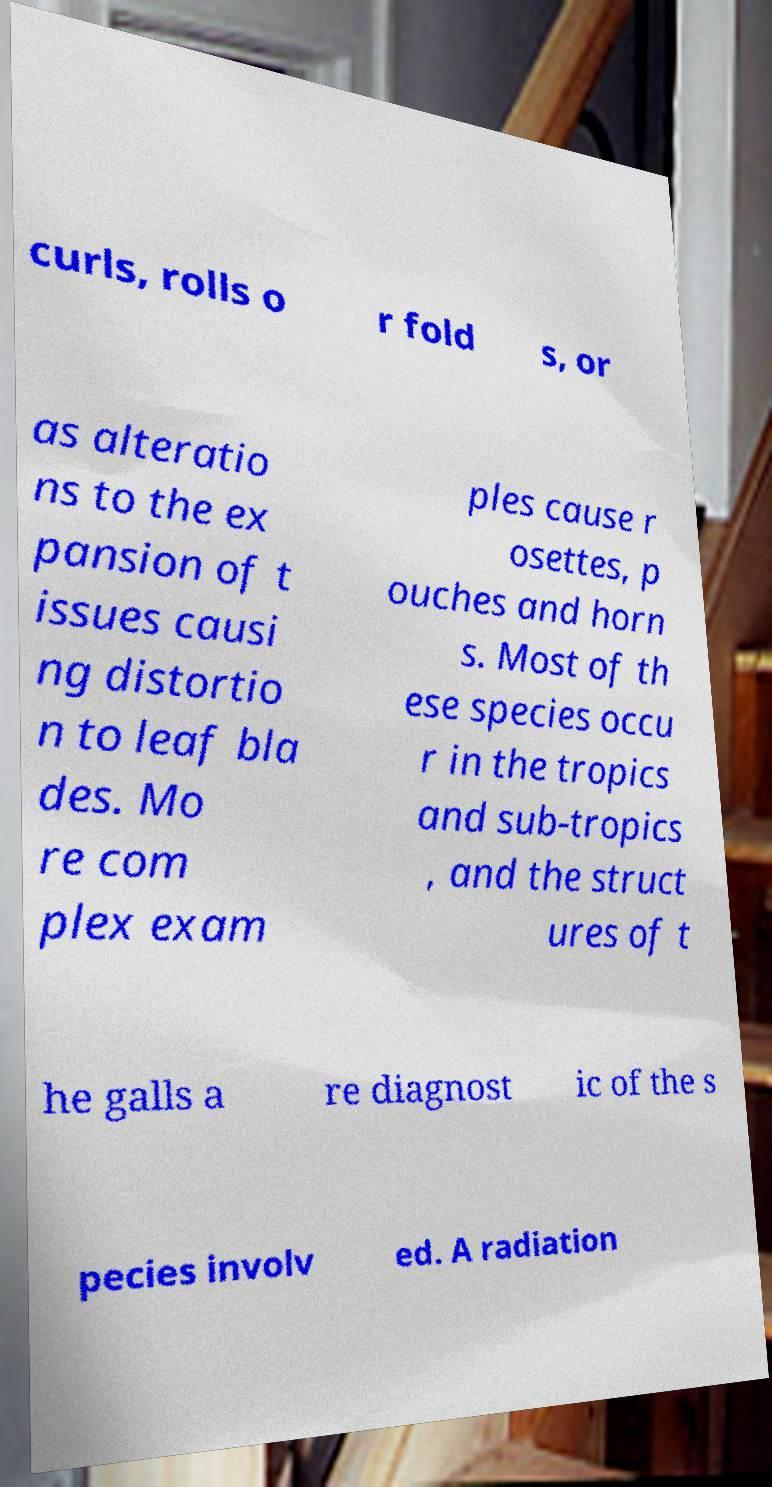Please identify and transcribe the text found in this image. curls, rolls o r fold s, or as alteratio ns to the ex pansion of t issues causi ng distortio n to leaf bla des. Mo re com plex exam ples cause r osettes, p ouches and horn s. Most of th ese species occu r in the tropics and sub-tropics , and the struct ures of t he galls a re diagnost ic of the s pecies involv ed. A radiation 